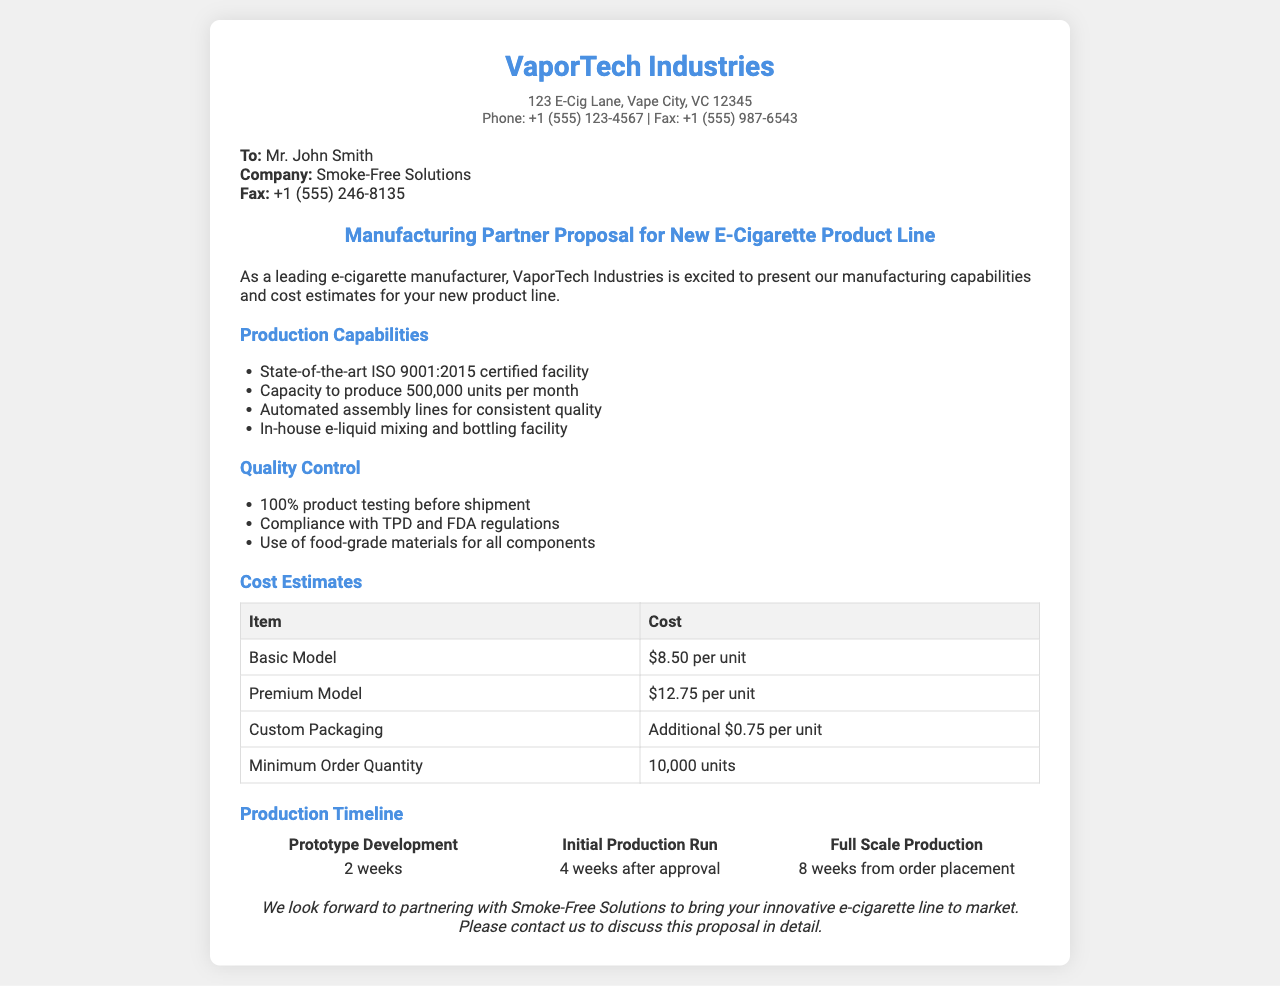what is the company name? The company name is mentioned at the top of the document as VaporTech Industries.
Answer: VaporTech Industries who is the recipient of the fax? The recipient's name is listed in the document under the recipient section as Mr. John Smith.
Answer: Mr. John Smith what is the production capacity per month? The production capacity is provided in the production capabilities section as 500,000 units per month.
Answer: 500,000 units per month what are the cost estimates for the Basic Model? The cost for the Basic Model is clearly stated in the cost estimates table as $8.50 per unit.
Answer: $8.50 per unit how long does it take for the prototype development? The timeline section specifies that prototype development takes 2 weeks.
Answer: 2 weeks what is the minimum order quantity? The minimum order quantity is mentioned in the cost estimates table as 10,000 units.
Answer: 10,000 units how many weeks from order placement for full scale production? The timeline section indicates that full scale production takes 8 weeks from order placement.
Answer: 8 weeks which certification does the facility have? The document states that the facility is ISO 9001:2015 certified.
Answer: ISO 9001:2015 